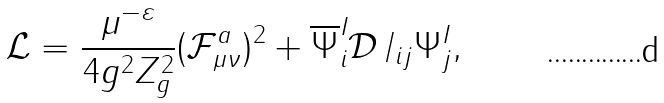Convert formula to latex. <formula><loc_0><loc_0><loc_500><loc_500>\mathcal { L } = \frac { \mu ^ { - \varepsilon } } { 4 g ^ { 2 } Z _ { g } ^ { 2 } } ( \mathcal { F } _ { \mu \nu } ^ { a } ) ^ { 2 } + \overline { \Psi } _ { i } ^ { I } \mathcal { D } \, \slash _ { i j } \Psi _ { j } ^ { I } ,</formula> 